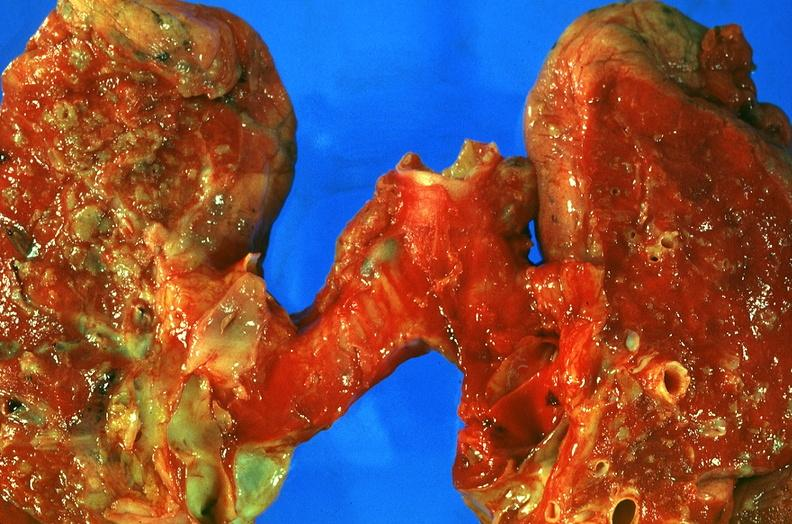what does this image show?
Answer the question using a single word or phrase. Lung 